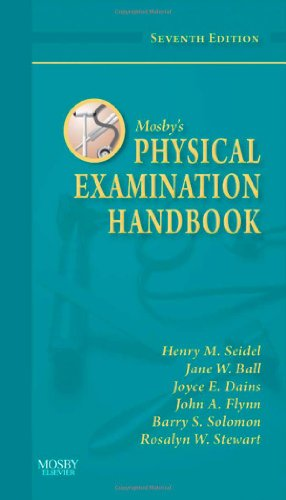Is this book related to Politics & Social Sciences? No, this book is not related to Politics & Social Sciences; it is strictly a medical reference manual centered on physical examination skills. 